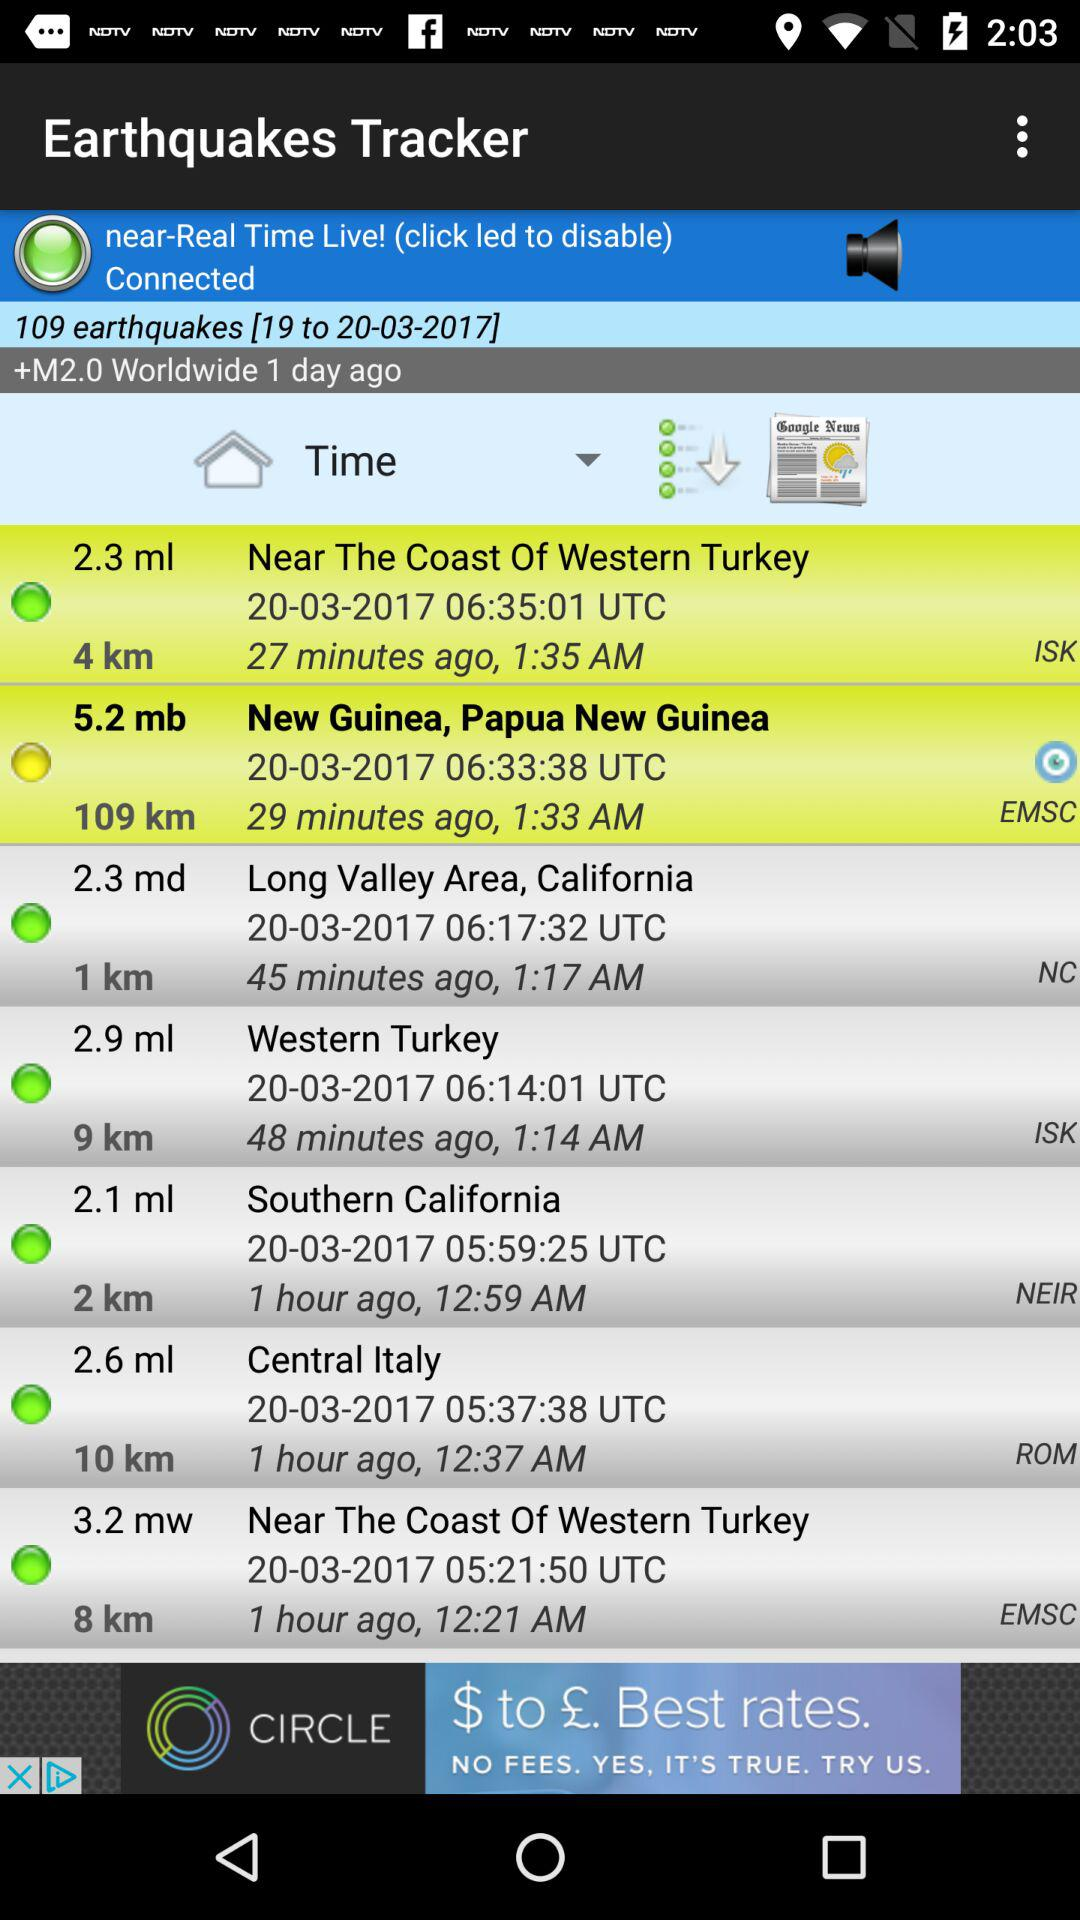What is the number of earthquakes given? The number of earthquakes given is 109. 